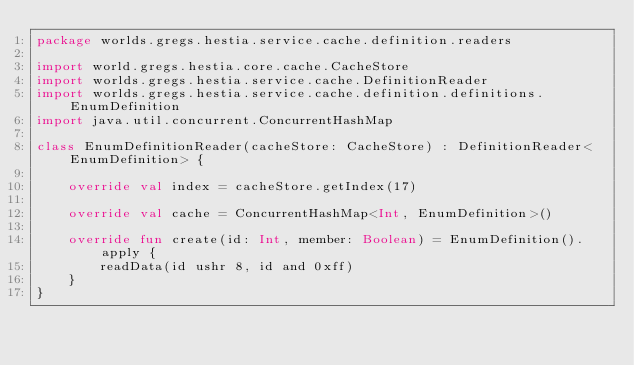<code> <loc_0><loc_0><loc_500><loc_500><_Kotlin_>package worlds.gregs.hestia.service.cache.definition.readers

import world.gregs.hestia.core.cache.CacheStore
import worlds.gregs.hestia.service.cache.DefinitionReader
import worlds.gregs.hestia.service.cache.definition.definitions.EnumDefinition
import java.util.concurrent.ConcurrentHashMap

class EnumDefinitionReader(cacheStore: CacheStore) : DefinitionReader<EnumDefinition> {

    override val index = cacheStore.getIndex(17)

    override val cache = ConcurrentHashMap<Int, EnumDefinition>()

    override fun create(id: Int, member: Boolean) = EnumDefinition().apply {
        readData(id ushr 8, id and 0xff)
    }
}</code> 